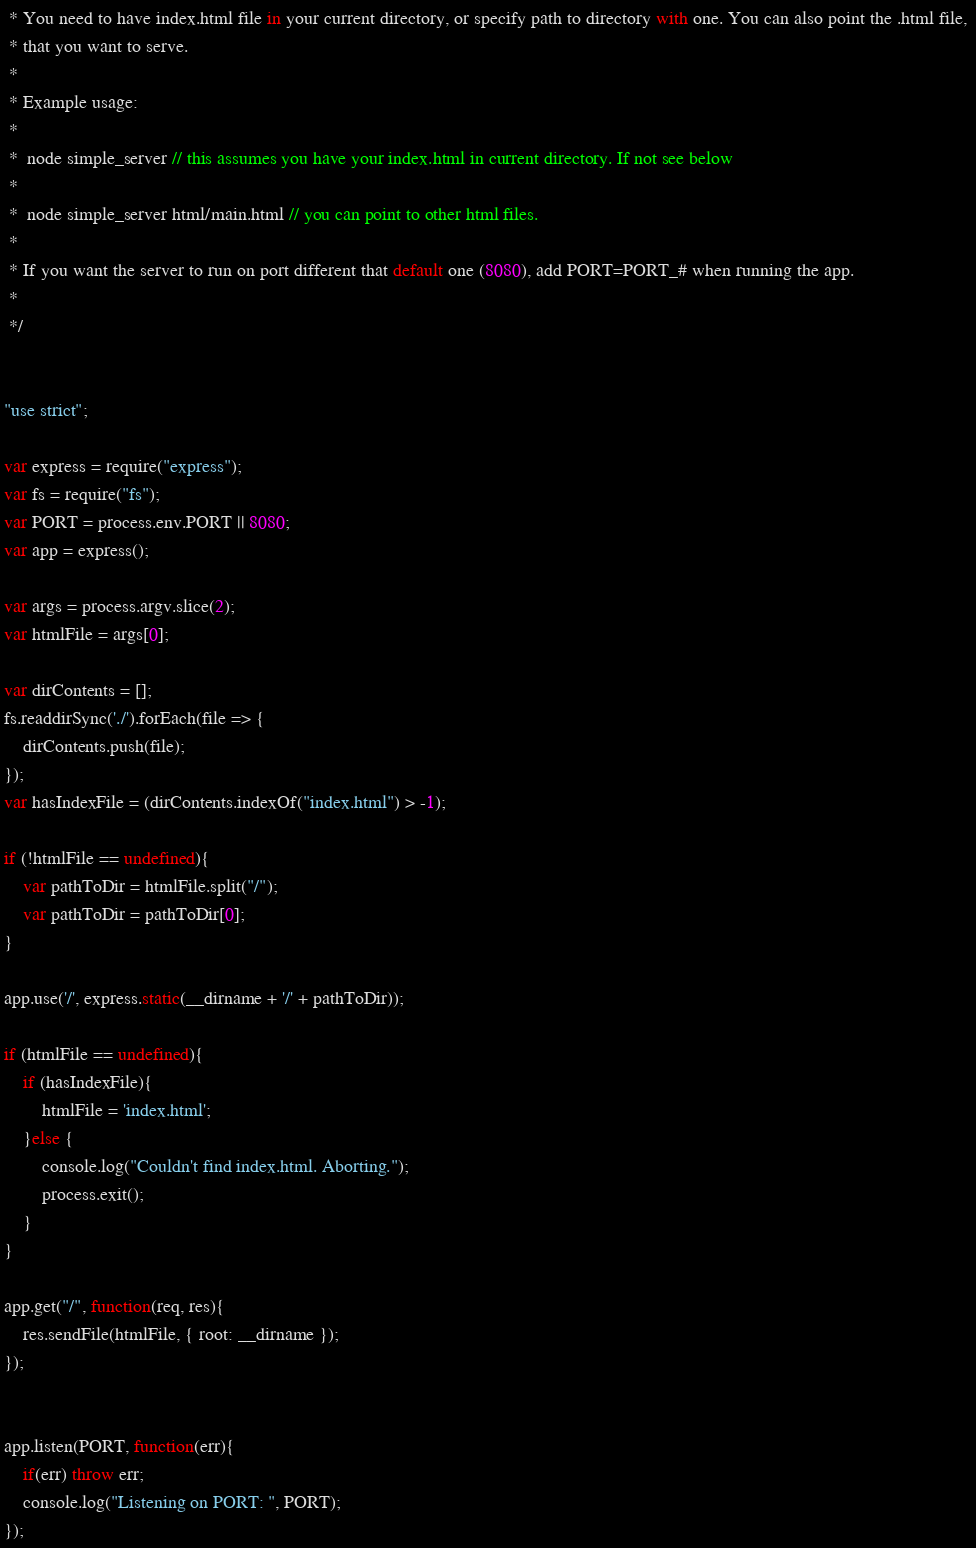<code> <loc_0><loc_0><loc_500><loc_500><_JavaScript_> * You need to have index.html file in your current directory, or specify path to directory with one. You can also point the .html file, 
 * that you want to serve.
 * 
 * Example usage: 
 *
 *  node simple_server // this assumes you have your index.html in current directory. If not see below
 *
 *  node simple_server html/main.html // you can point to other html files.
 *
 * If you want the server to run on port different that default one (8080), add PORT=PORT_# when running the app.
 *
 */


"use strict";

var express = require("express");
var fs = require("fs");
var PORT = process.env.PORT || 8080; 
var app = express();

var args = process.argv.slice(2);
var htmlFile = args[0];

var dirContents = [];
fs.readdirSync('./').forEach(file => {
	dirContents.push(file);
});
var hasIndexFile = (dirContents.indexOf("index.html") > -1);

if (!htmlFile == undefined){
	var pathToDir = htmlFile.split("/");
	var pathToDir = pathToDir[0];
}

app.use('/', express.static(__dirname + '/' + pathToDir));

if (htmlFile == undefined){
	if (hasIndexFile){
		htmlFile = 'index.html';
	}else {
		console.log("Couldn't find index.html. Aborting.");
		process.exit();
	}
}

app.get("/", function(req, res){
	res.sendFile(htmlFile, { root: __dirname });	
});


app.listen(PORT, function(err){
	if(err) throw err;
	console.log("Listening on PORT: ", PORT); 
});
</code> 